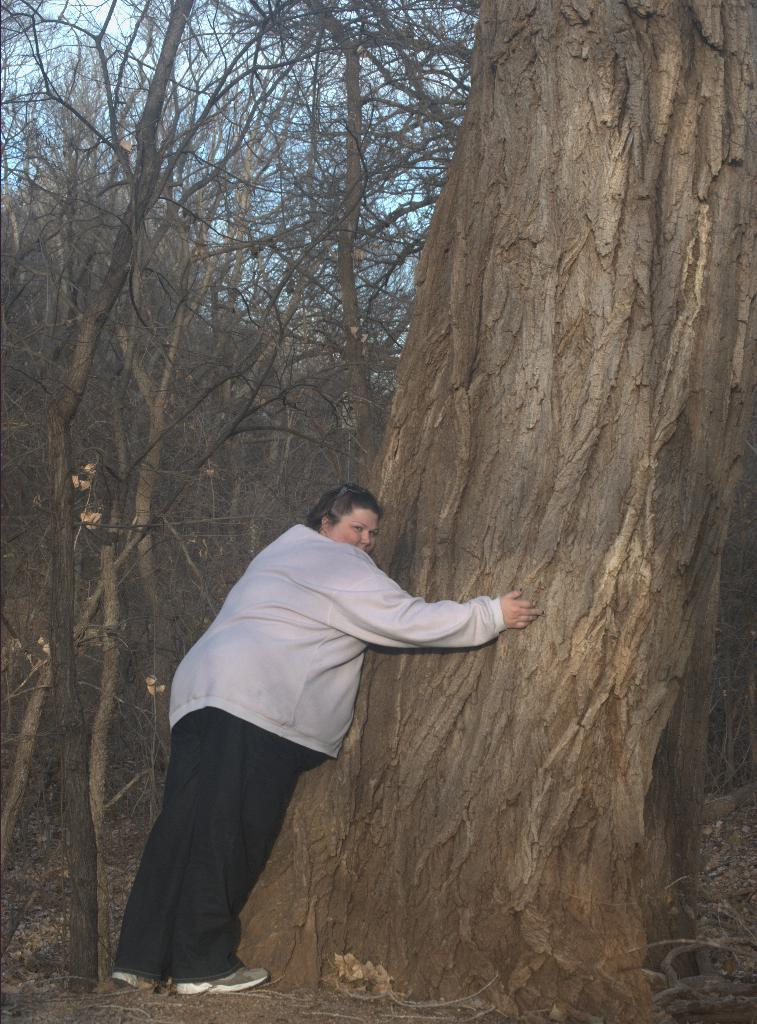Who or what is present in the image? There is a person in the image. What is the person doing in the image? The person is standing near a tree. What verse is the person reciting in the image? There is no indication in the image that the person is reciting a verse, so it cannot be determined from the picture. 